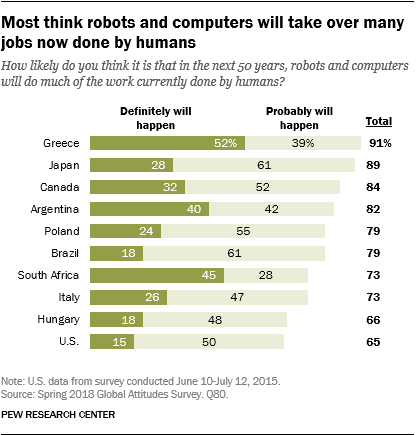List a handful of essential elements in this visual. The average value in Definitely will happen, Probably will happen, and total in Canada is 168. The highest value in total represents Greece. 